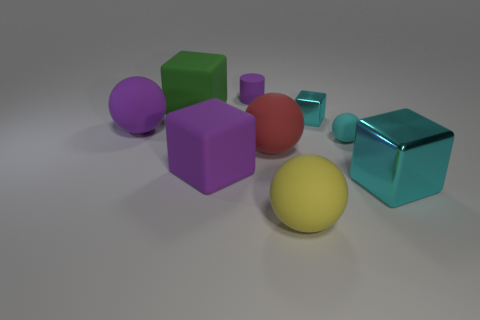Subtract 1 blocks. How many blocks are left? 3 Add 1 tiny blocks. How many objects exist? 10 Subtract all spheres. How many objects are left? 5 Add 9 blue blocks. How many blue blocks exist? 9 Subtract 1 yellow balls. How many objects are left? 8 Subtract all green rubber objects. Subtract all small cyan shiny blocks. How many objects are left? 7 Add 2 spheres. How many spheres are left? 6 